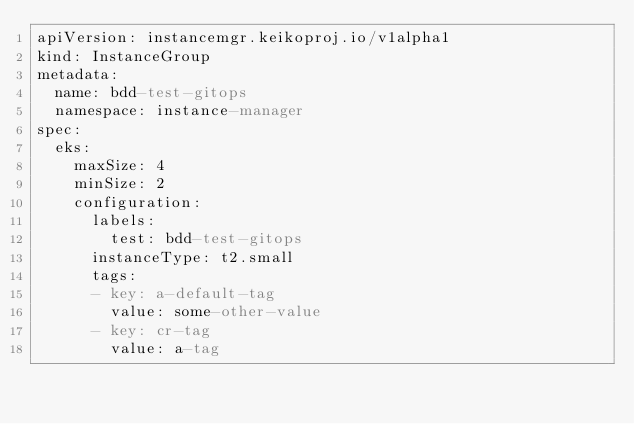<code> <loc_0><loc_0><loc_500><loc_500><_YAML_>apiVersion: instancemgr.keikoproj.io/v1alpha1
kind: InstanceGroup
metadata:
  name: bdd-test-gitops
  namespace: instance-manager
spec:
  eks:
    maxSize: 4
    minSize: 2
    configuration:
      labels:
        test: bdd-test-gitops
      instanceType: t2.small
      tags:
      - key: a-default-tag
        value: some-other-value
      - key: cr-tag
        value: a-tag
</code> 